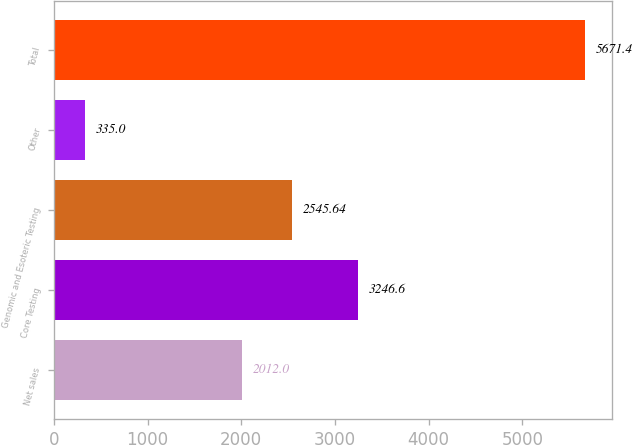<chart> <loc_0><loc_0><loc_500><loc_500><bar_chart><fcel>Net sales<fcel>Core Testing<fcel>Genomic and Esoteric Testing<fcel>Other<fcel>Total<nl><fcel>2012<fcel>3246.6<fcel>2545.64<fcel>335<fcel>5671.4<nl></chart> 